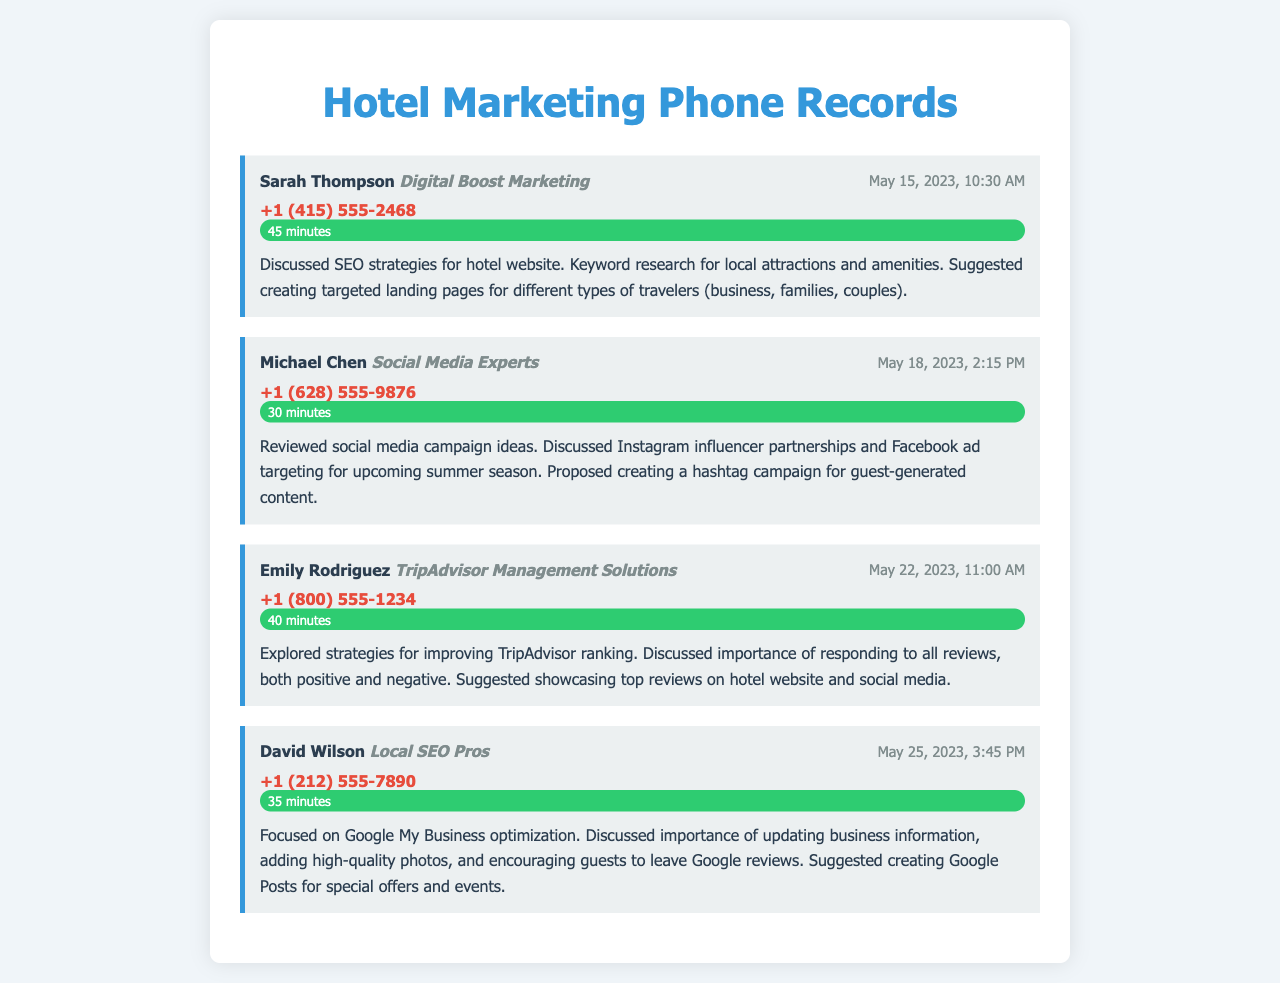What is the name of the first marketing contact? The first marketing contact mentioned in the document is Sarah Thompson.
Answer: Sarah Thompson Which company did Michael Chen represent? Michael Chen was representing Social Media Experts during the conversation.
Answer: Social Media Experts What was the duration of the call with Emily Rodriguez? The call with Emily Rodriguez lasted 40 minutes.
Answer: 40 minutes On which date did the discussion with David Wilson take place? The discussion with David Wilson occurred on May 25, 2023.
Answer: May 25, 2023 What topic was covered in the call with Digital Boost Marketing? The call with Digital Boost Marketing focused on SEO strategies for the hotel website.
Answer: SEO strategies for hotel website Which marketing approach did Social Media Experts propose? Social Media Experts proposed creating a hashtag campaign for guest-generated content.
Answer: Hashtag campaign What is the significance of responding to reviews according to Emily Rodriguez? According to Emily Rodriguez, responding to all reviews is important for improving TripAdvisor ranking.
Answer: Improving TripAdvisor ranking Which platform did David Wilson discuss for optimization? David Wilson discussed Google My Business for optimization.
Answer: Google My Business What is the phone number for the first marketing contact? The phone number for Sarah Thompson is +1 (415) 555-2468.
Answer: +1 (415) 555-2468 